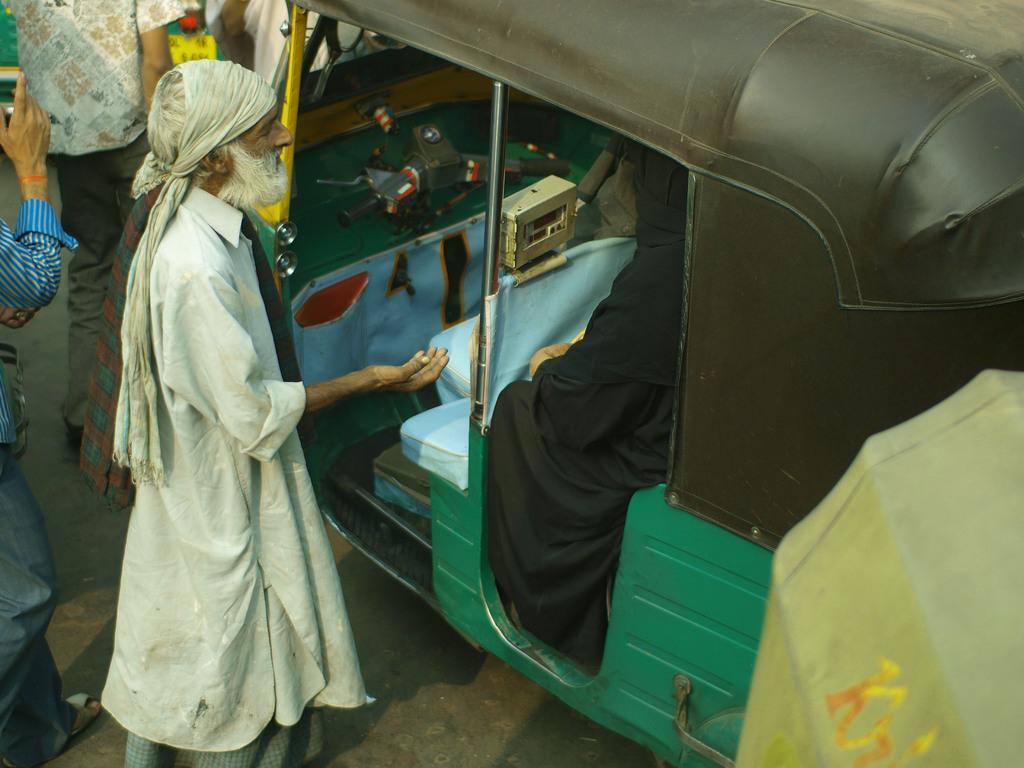Could you give a brief overview of what you see in this image? The man on the left side is standing beside the auto. We see the woman in the black dress is sitting in the auto. This photo is in black, yellow and green color. On the left side, we see people are standing on the road. The man in the blue shirt is holding a mobile phone in his hands. This picture might be clicked outside the city. 